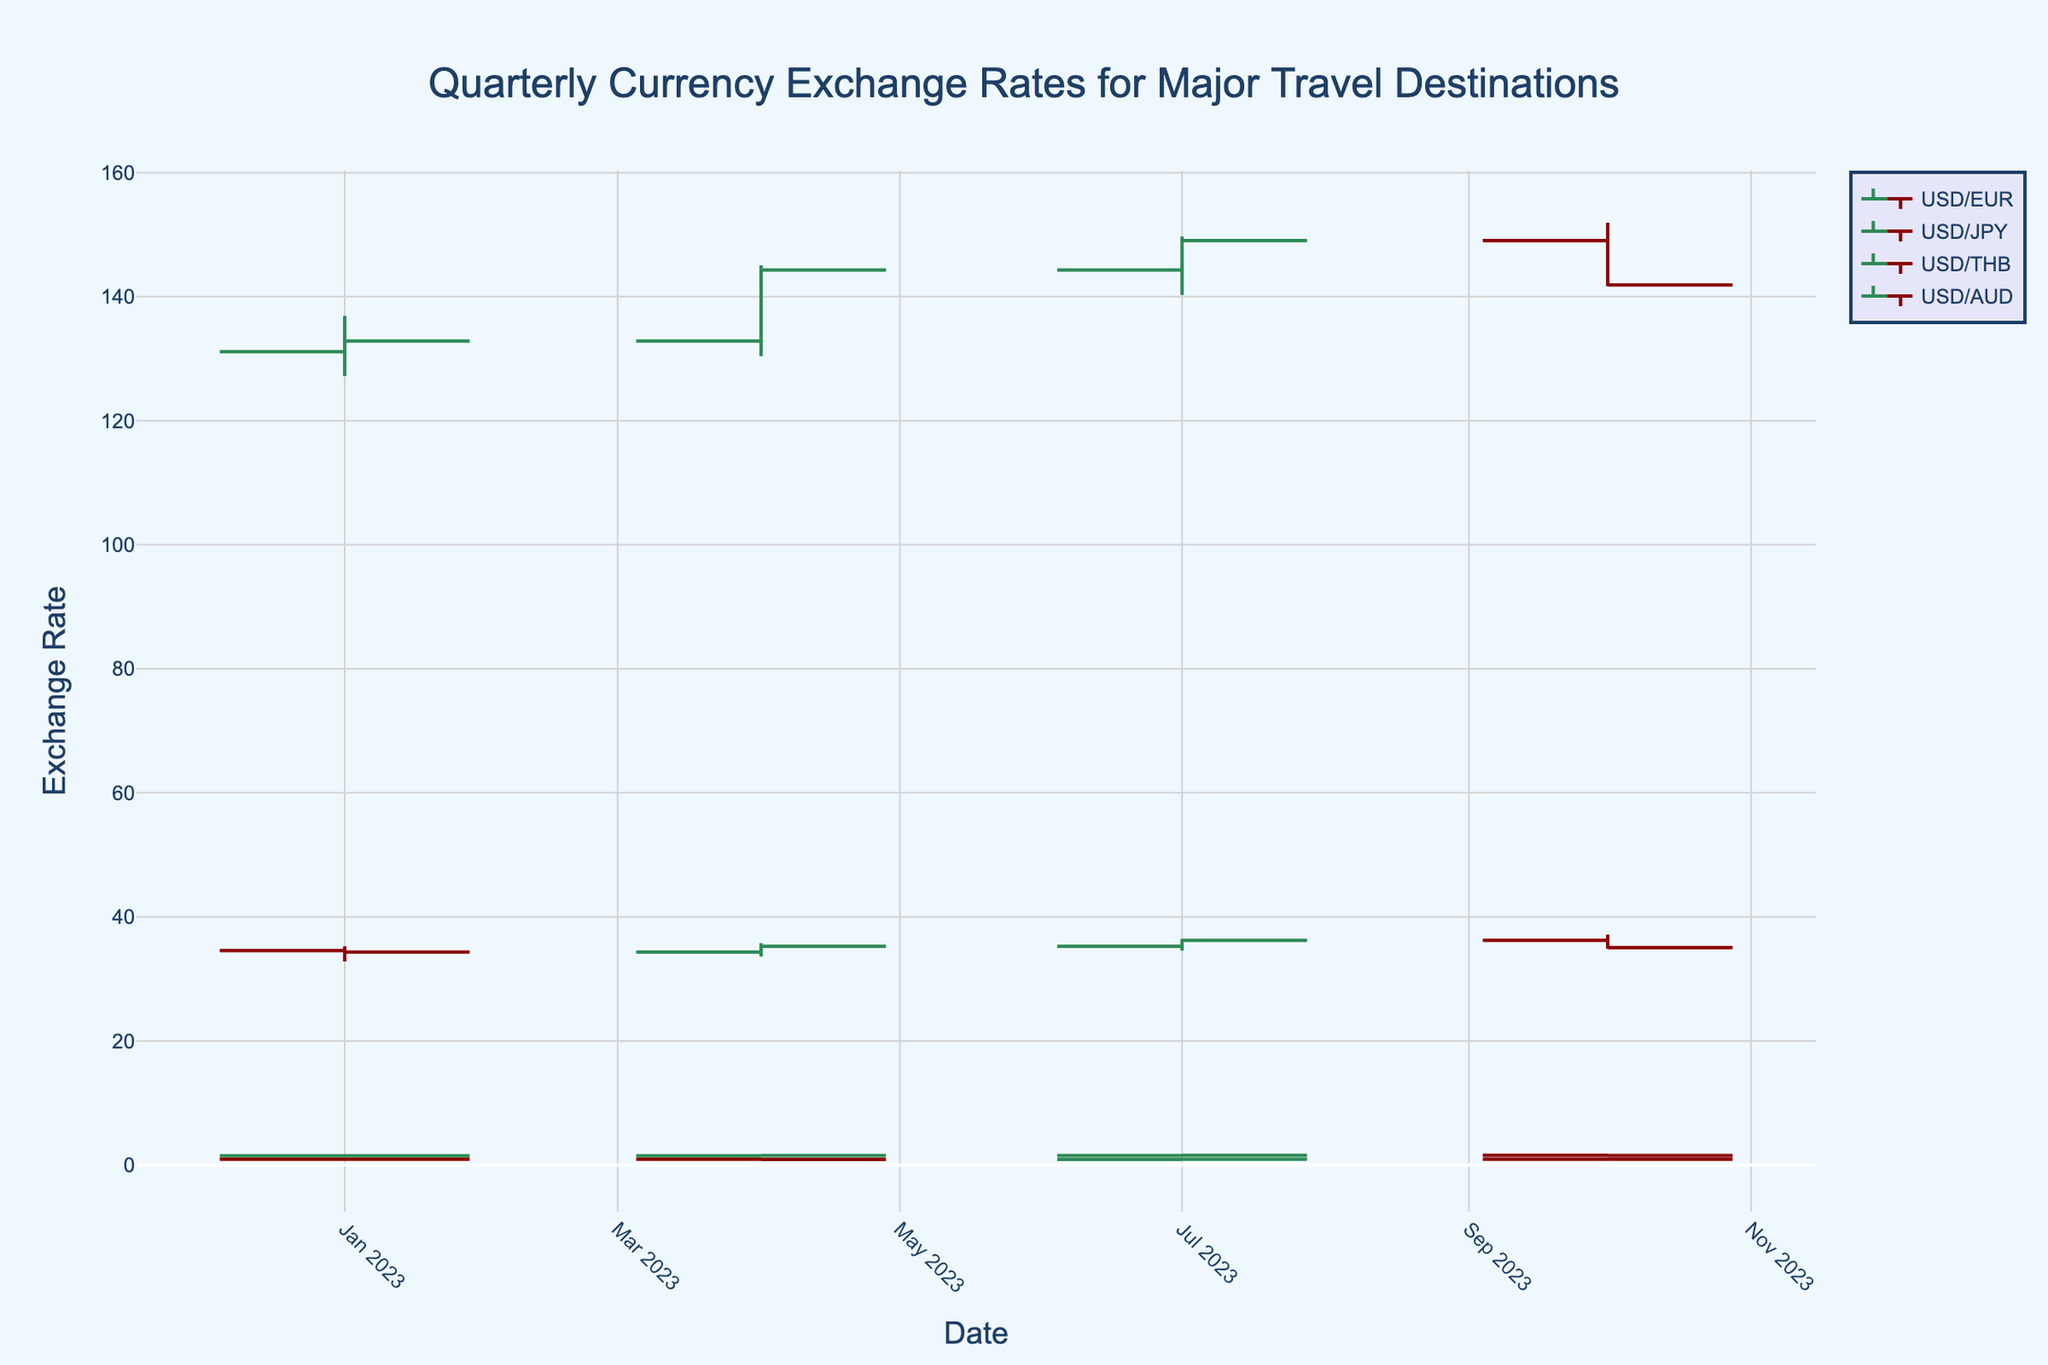what is the overall trend for the USD/EUR pair from Q1 to Q4 of 2023? To determine the overall trend for the USD/EUR pair, we should analyze the opening and closing values across the quarters. 
In Q1, the opening value is 0.9382, and the closing value is 0.9236, indicating a decrease. 
In Q2, the opening value is 0.9236, and the closing value is 0.9175, suggesting a slight decrease. 
In Q3, the opening value is 0.9175, and the closing value is 0.9465, indicating an increase. 
In Q4, the opening value is 0.9465, and the closing value is 0.9246, indicating a decrease. Summarizing these observations, the overall trend for USD/EUR in 2023 is mostly a decrease, with a notable increase in Q3.
Answer: Mostly a decrease Which quarter had the largest range (difference between high and low) for the USD/JPY pair? To find the quarter with the largest range, subtract the low value from the high value for each quarter:
Q1: 136.91 - 127.22 = 9.69
Q2: 145.07 - 130.41 = 14.66
Q3: 149.71 - 140.27 = 9.44
Q4: 151.94 - 141.68 = 10.26
Comparing these ranges, Q2 has the largest difference, which is 14.66.
Answer: Q2 How did the USD/THB pair performance change from Q1 to Q4 of 2023? Examine the opening and closing values for each quarter to assess the performance:
Q1: Open - 34.56, Close - 34.33 (decrease)
Q2: Open - 34.33, Close - 35.27 (increase)
Q3: Open - 35.27, Close - 36.22 (increase)
Q4: Open - 36.22, Close - 35.06 (decrease)
From this analysis, the USD/THB pair shows an initial decrease in Q1, an increase in Q2 and Q3, followed by a decrease in Q4. Overall, it increases between Q1 and Q4.
Answer: Overall increase Which currency pair had the highest closing value in Q4 of 2023? Compare the closing values of all currency pairs in Q4:
USD/EUR: 0.9246
USD/JPY: 141.91
USD/THB: 35.06
USD/AUD: 1.5271
The highest closing value among these pairs is for USD/JPY, which is 141.91.
Answer: USD/JPY What was the trend for the USD/AUD pair, and which quarter showed the maximum increase? Review the opening and closing values for each quarter:
Q1: Open - 1.4739, Close - 1.4912 (increase)
Q2: Open - 1.4912, Close - 1.5088 (increase)
Q3: Open - 1.5088, Close - 1.5573 (increase)
Q4: Open - 1.5573, Close - 1.5271 (decrease)
The USD/AUD pair showed an increasing trend from Q1 to Q3, with a maximum increase in Q3 where it went from 1.5088 to 1.5573.
Answer: Increasing trend, maximum increase in Q3 What's the difference in closing values between USD/EUR and USD/JPY in Q4 of 2023? To find the difference, subtract the closing value of USD/EUR from the closing value of USD/JPY in Q4:
141.91 (USD/JPY) - 0.9246 (USD/EUR) = 140.9854
Thus, the difference in closing values between USD/EUR and USD/JPY is 140.9854.
Answer: 140.9854 